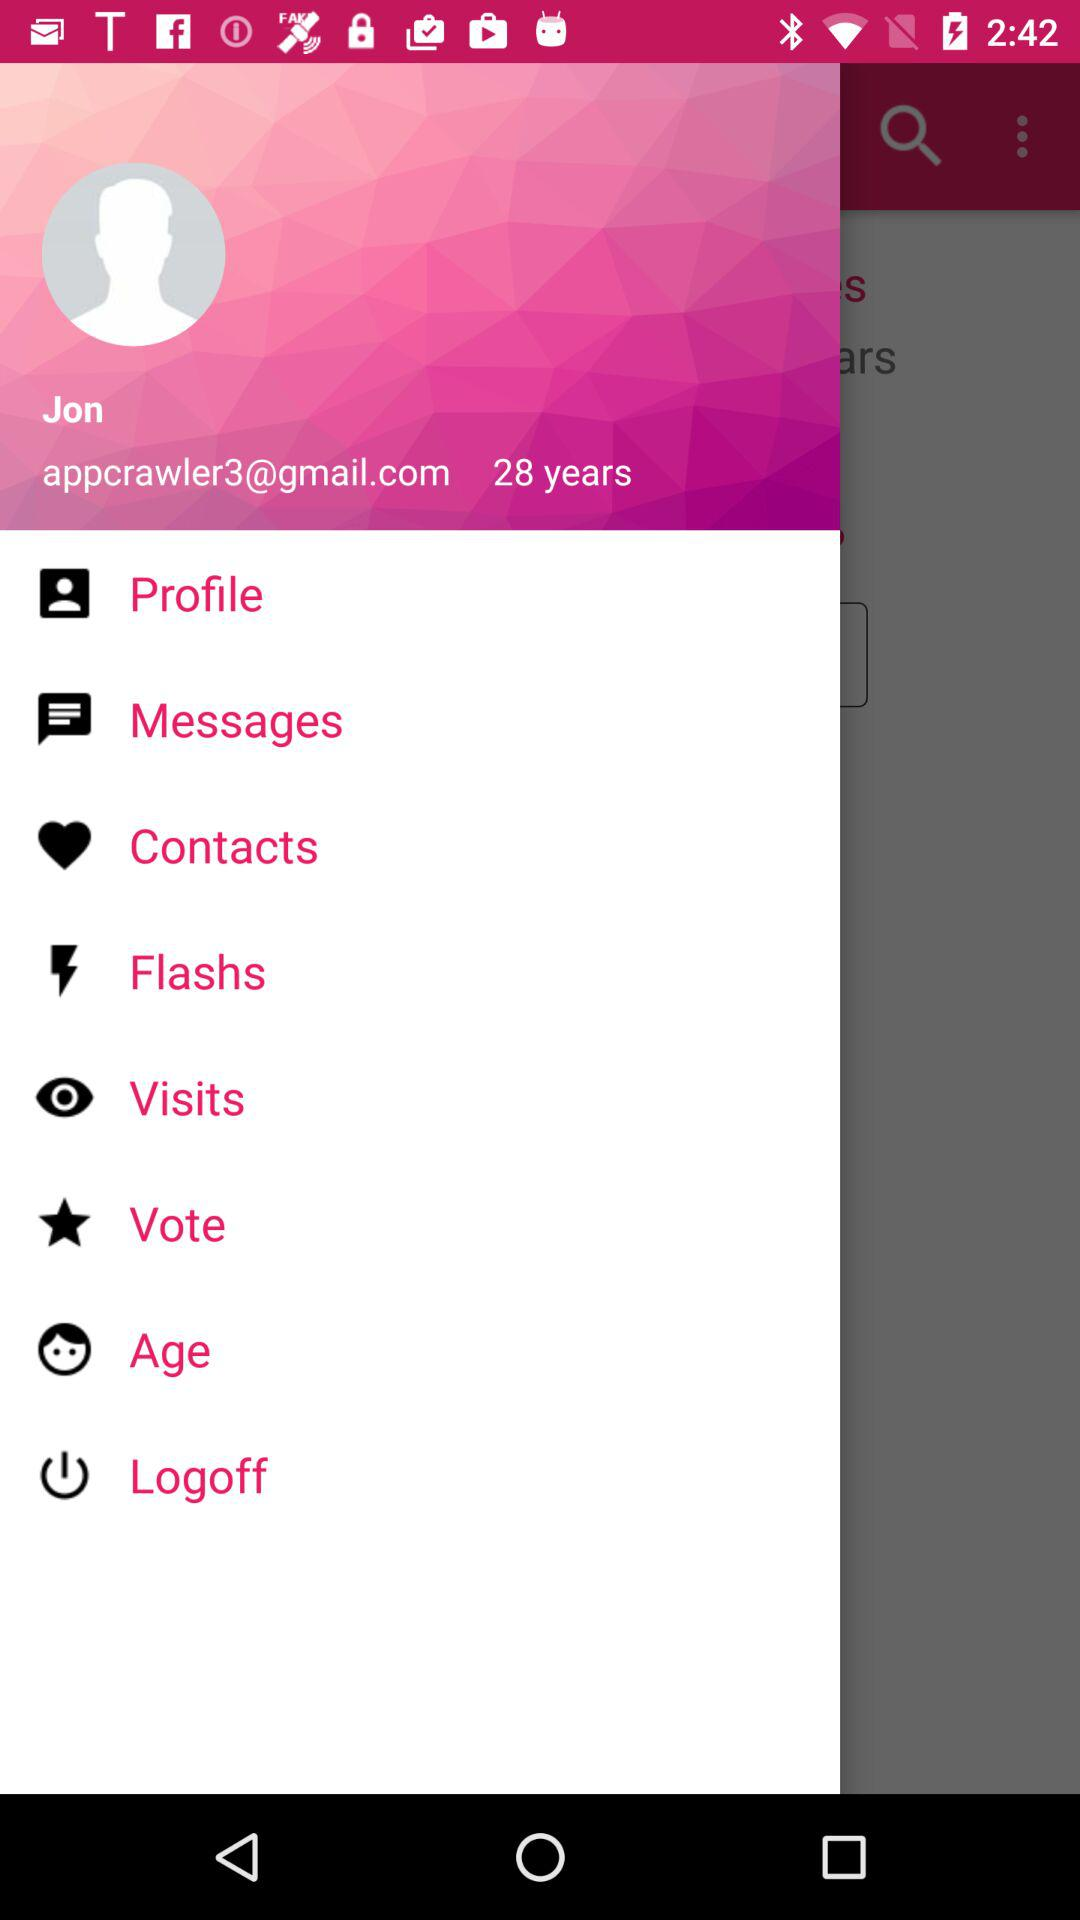What is the age of Jon? Jon's age is 28 years old. 